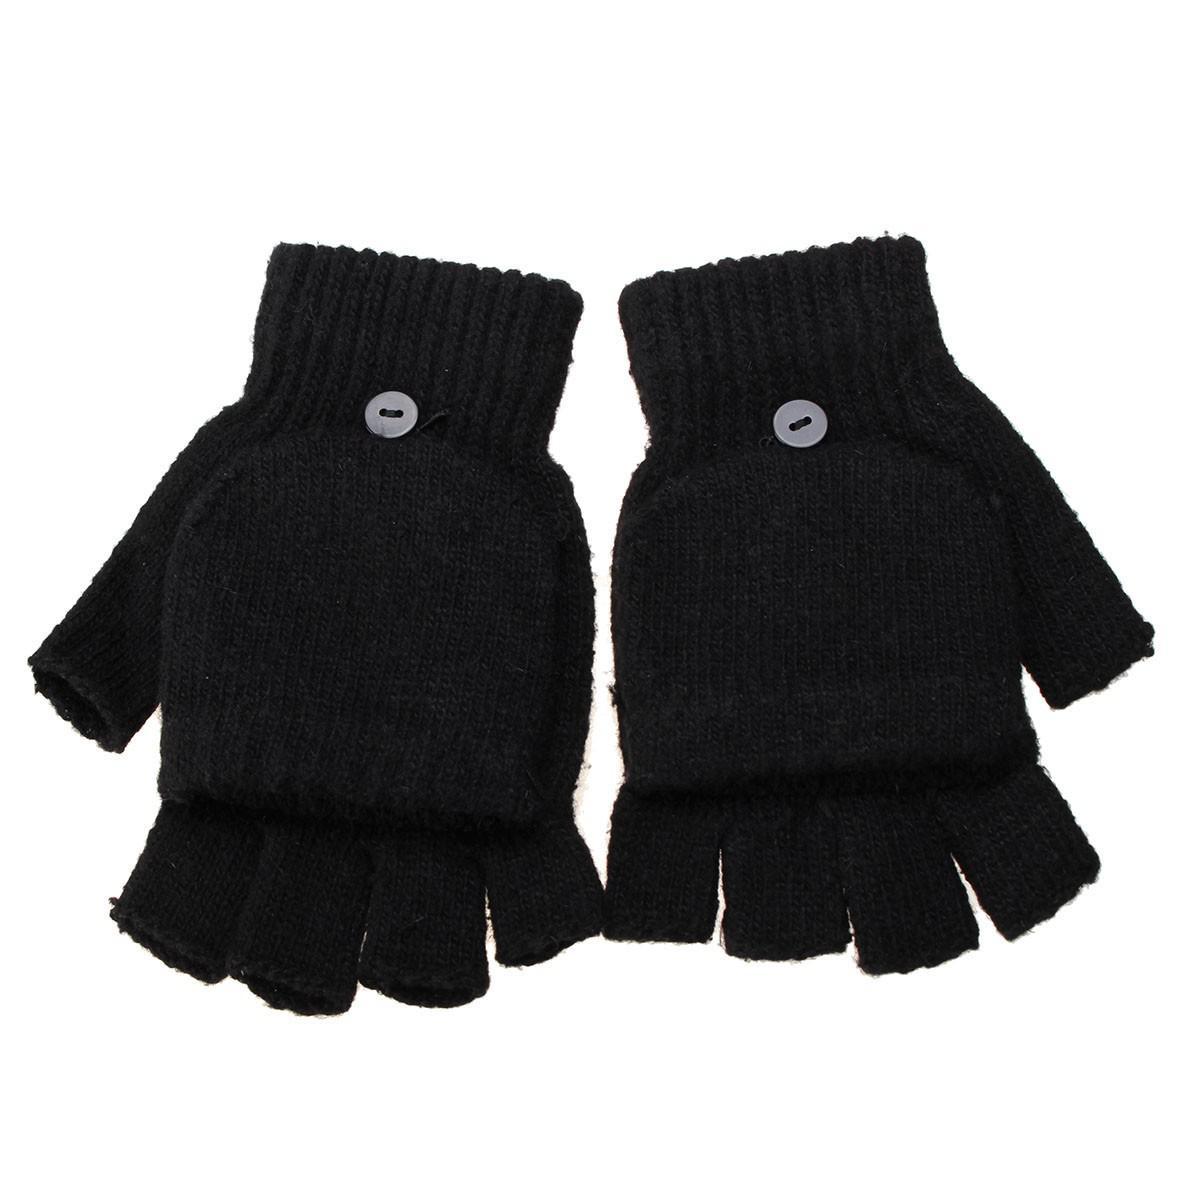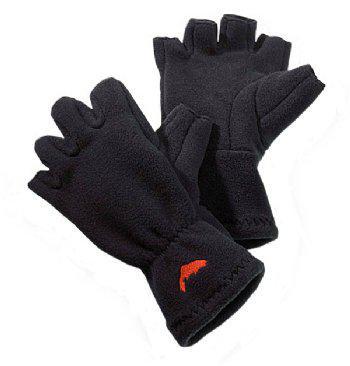The first image is the image on the left, the second image is the image on the right. Evaluate the accuracy of this statement regarding the images: "A glove is on a single hand in the image on the left.". Is it true? Answer yes or no. No. 